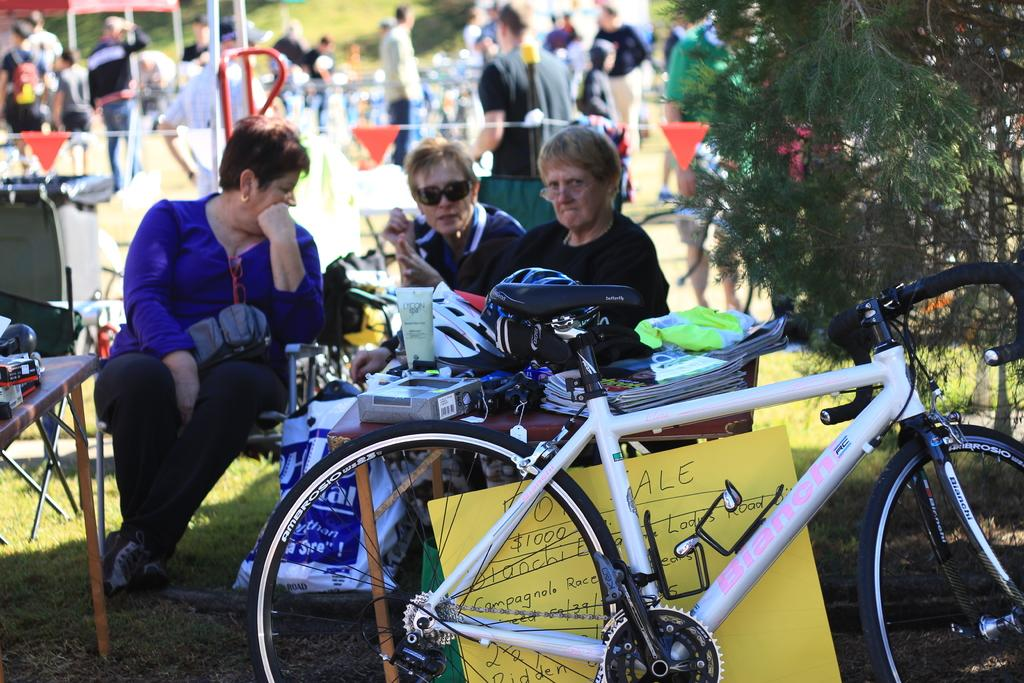How many people are in the image? There is a group of people in the image, but the exact number is not specified. What are some of the people doing in the image? Some of the people are sitting on chairs. What can be seen in the image besides the people and chairs? There is a cycle, a tree, a box on a table, and additional items on the table. What type of patch can be seen on the cycle in the image? There is no patch visible on the cycle in the image. What sound do the bells make in the image? There are no bells present in the image. 